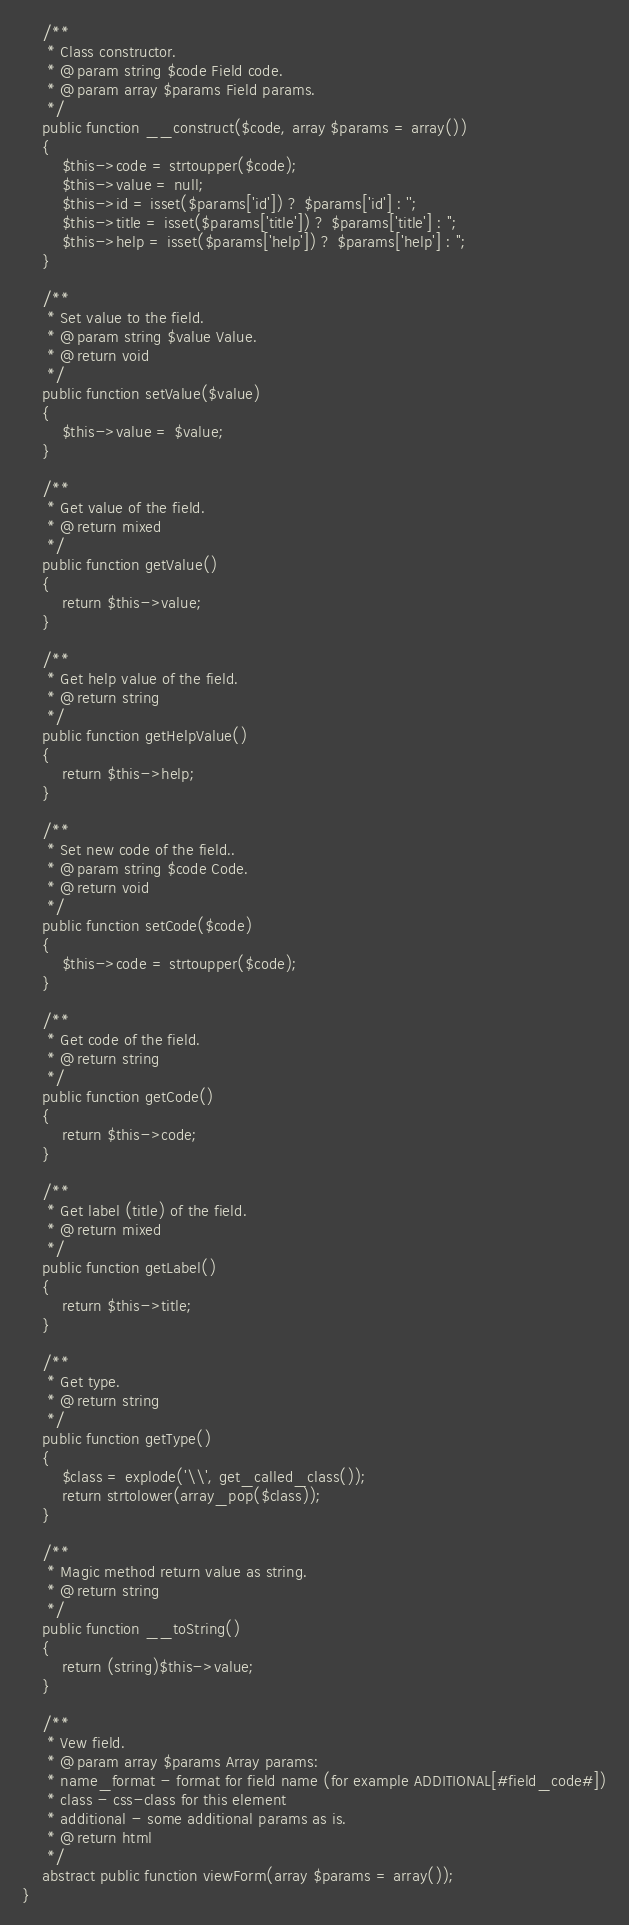Convert code to text. <code><loc_0><loc_0><loc_500><loc_500><_PHP_>	/**
	 * Class constructor.
	 * @param string $code Field code.
	 * @param array $params Field params.
	 */
	public function __construct($code, array $params = array())
	{
		$this->code = strtoupper($code);
		$this->value = null;
		$this->id = isset($params['id']) ? $params['id'] : '';
		$this->title = isset($params['title']) ? $params['title'] : '';
		$this->help = isset($params['help']) ? $params['help'] : '';
	}

	/**
	 * Set value to the field.
	 * @param string $value Value.
	 * @return void
	 */
	public function setValue($value)
	{
		$this->value = $value;
	}

	/**
	 * Get value of the field.
	 * @return mixed
	 */
	public function getValue()
	{
		return $this->value;
	}

	/**
	 * Get help value of the field.
	 * @return string
	 */
	public function getHelpValue()
	{
		return $this->help;
	}

	/**
	 * Set new code of the field..
	 * @param string $code Code.
	 * @return void
	 */
	public function setCode($code)
	{
		$this->code = strtoupper($code);
	}

	/**
	 * Get code of the field.
	 * @return string
	 */
	public function getCode()
	{
		return $this->code;
	}

	/**
	 * Get label (title) of the field.
	 * @return mixed
	 */
	public function getLabel()
	{
		return $this->title;
	}

	/**
	 * Get type.
	 * @return string
	 */
	public function getType()
	{
		$class = explode('\\', get_called_class());
		return strtolower(array_pop($class));
	}

	/**
	 * Magic method return value as string.
	 * @return string
	 */
	public function __toString()
	{
		return (string)$this->value;
	}

	/**
	 * Vew field.
	 * @param array $params Array params:
	 * name_format - format for field name (for example ADDITIONAL[#field_code#])
	 * class - css-class for this element
	 * additional - some additional params as is.
	 * @return html
	 */
	abstract public function viewForm(array $params = array());
}</code> 